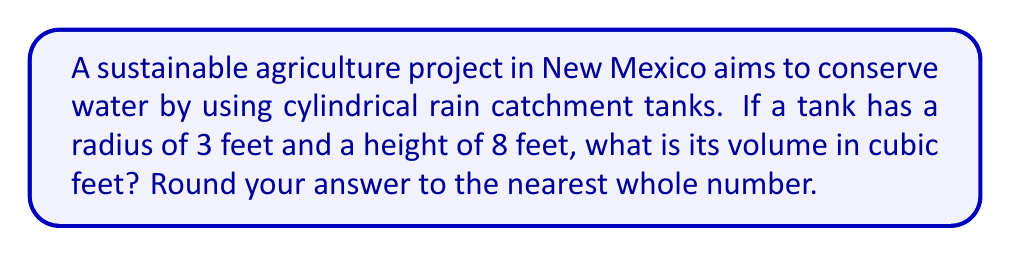Give your solution to this math problem. To solve this problem, we'll use the formula for the volume of a cylinder:

$$V = \pi r^2 h$$

Where:
$V$ = volume
$\pi$ = pi (approximately 3.14159)
$r$ = radius of the base
$h$ = height of the cylinder

Given:
$r = 3$ feet
$h = 8$ feet

Let's substitute these values into our formula:

$$V = \pi (3\text{ ft})^2 (8\text{ ft})$$

Now, let's calculate step-by-step:

1) First, calculate $r^2$:
   $3^2 = 9$

2) Multiply by $\pi$:
   $\pi \cdot 9 = 28.27431$

3) Multiply by the height:
   $28.27431 \cdot 8 = 226.19448$

4) Round to the nearest whole number:
   $226.19448 \approx 226$

Therefore, the volume of the cylindrical water tank is approximately 226 cubic feet.
Answer: $226\text{ ft}^3$ 